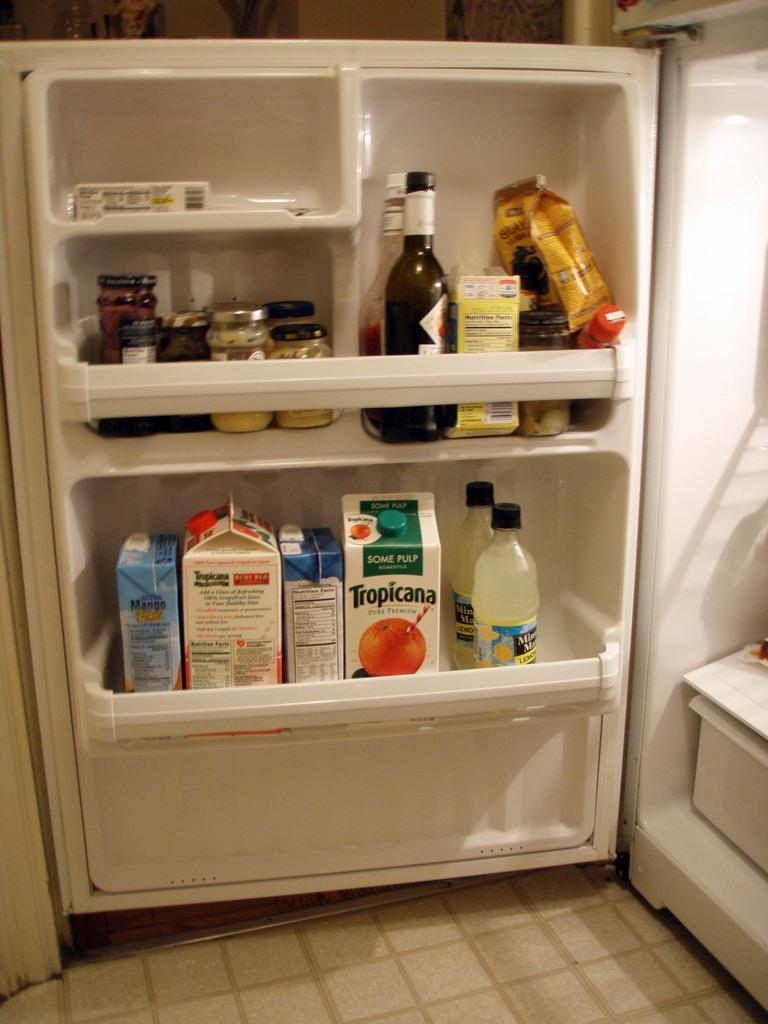What type of appliance is visible in the image? There is a refrigerator in the image. What items can be seen inside the refrigerator? There are bottles and cardboard boxes in the refrigerator. What type of art does the mom create in the image? There is no mention of a mom or any art in the image. 